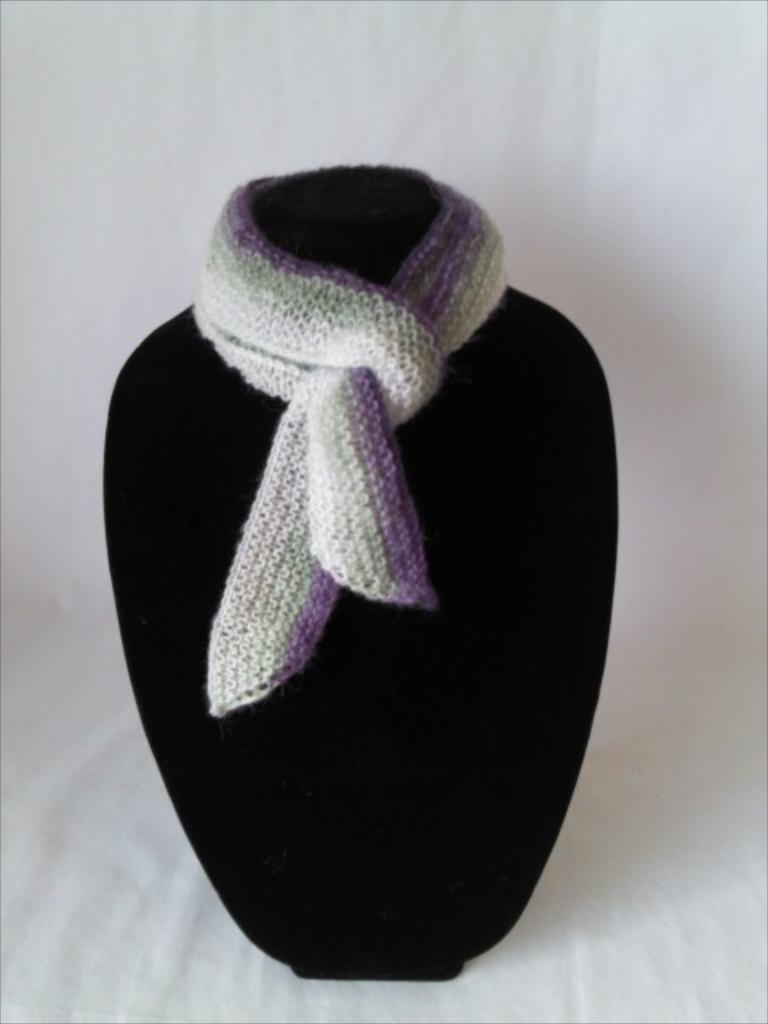What is the scarf placed on in the image? The scarf is placed on a black object in the image. What color is the background of the image? The background of the image is white. What type of pet can be seen playing with waves in the image? There is no pet or waves present in the image; it only features a scarf on a black object with a white background. 